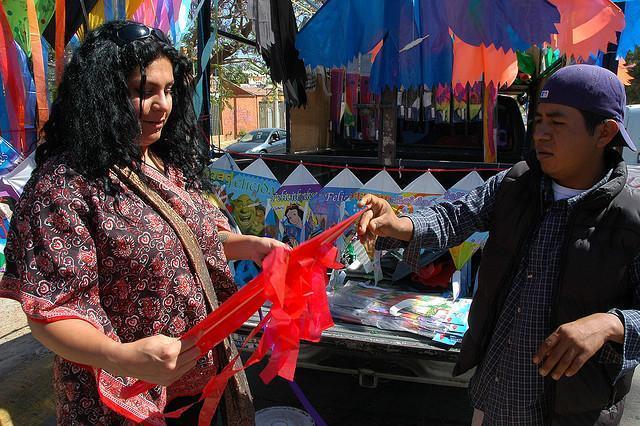How many people are wearing hats?
Give a very brief answer. 1. How many color on her shirt?
Give a very brief answer. 4. How many kites are in the picture?
Give a very brief answer. 5. How many people are in the photo?
Give a very brief answer. 2. How many mufflers does the bike have?
Give a very brief answer. 0. 